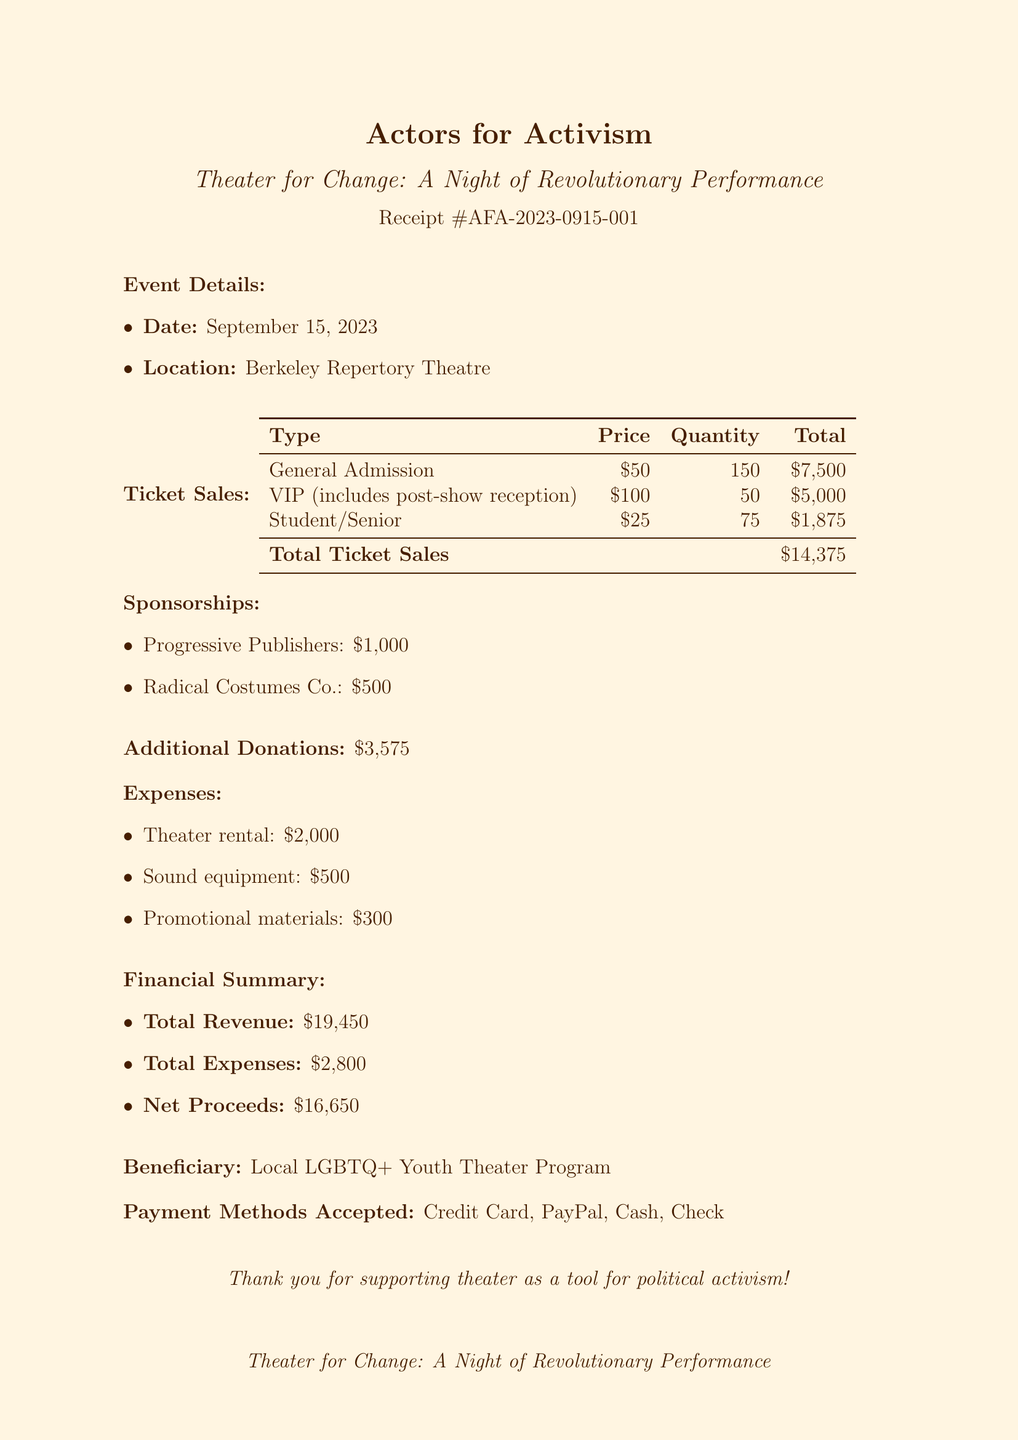what is the event name? The event name is specified at the top of the document and is a key feature of the receipt.
Answer: Theater for Change: A Night of Revolutionary Performance what is the date of the event? The date is listed in the event details section of the document.
Answer: September 15, 2023 how many General Admission tickets were sold? The quantity of General Admission tickets sold is detailed in the ticket sales breakdown.
Answer: 150 what is the total amount raised from additional donations? The total from additional donations is stated clearly in the document.
Answer: $3,575 who is the beneficiary of the event? The beneficiary is mentioned explicitly in the financial summary section of the document.
Answer: Local LGBTQ+ Youth Theater Program what was the total revenue generated? Total revenue is calculated and summarized in the financial section of the document.
Answer: $19,450 how many VIP tickets were sold? The number of VIP tickets sold is included in the ticket sales section.
Answer: 50 what was the cost of theater rental? The cost of theater rental is listed in the expenses section of the document.
Answer: $2,000 which company sponsored the event with $1,000? The sponsoring companies are detailed in the sponsorships section with their corresponding amounts.
Answer: Progressive Publishers 